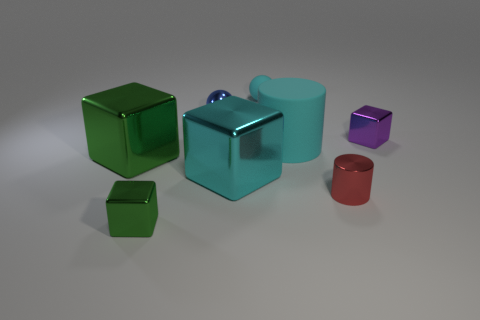Subtract all green cubes. How many were subtracted if there are1green cubes left? 1 Subtract 2 cubes. How many cubes are left? 2 Add 1 yellow spheres. How many objects exist? 9 Subtract all brown blocks. Subtract all cyan cylinders. How many blocks are left? 4 Subtract 0 gray cubes. How many objects are left? 8 Subtract all spheres. How many objects are left? 6 Subtract all big green shiny blocks. Subtract all big blue metal spheres. How many objects are left? 7 Add 6 cyan spheres. How many cyan spheres are left? 7 Add 3 shiny cylinders. How many shiny cylinders exist? 4 